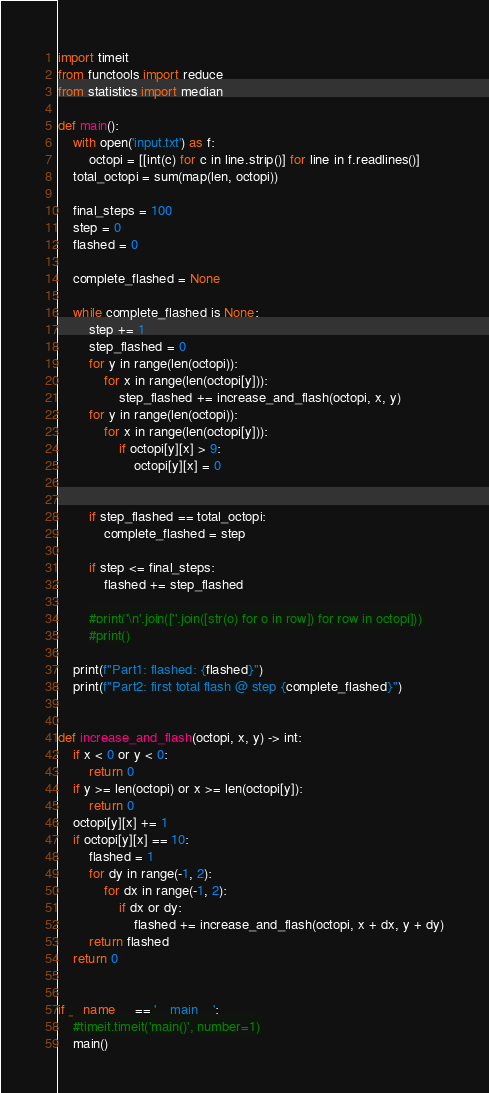Convert code to text. <code><loc_0><loc_0><loc_500><loc_500><_Python_>import timeit
from functools import reduce
from statistics import median

def main():
    with open('input.txt') as f:
        octopi = [[int(c) for c in line.strip()] for line in f.readlines()]
    total_octopi = sum(map(len, octopi))
    
    final_steps = 100
    step = 0
    flashed = 0

    complete_flashed = None

    while complete_flashed is None:
        step += 1
        step_flashed = 0
        for y in range(len(octopi)):
            for x in range(len(octopi[y])):
                step_flashed += increase_and_flash(octopi, x, y)
        for y in range(len(octopi)):
            for x in range(len(octopi[y])):
                if octopi[y][x] > 9:
                    octopi[y][x] = 0
        
        
        if step_flashed == total_octopi:
            complete_flashed = step

        if step <= final_steps:
            flashed += step_flashed
    
        #print('\n'.join([''.join([str(o) for o in row]) for row in octopi]))
        #print()

    print(f"Part1: flashed: {flashed}")
    print(f"Part2: first total flash @ step {complete_flashed}")
    

def increase_and_flash(octopi, x, y) -> int:
    if x < 0 or y < 0:
        return 0
    if y >= len(octopi) or x >= len(octopi[y]):
        return 0
    octopi[y][x] += 1
    if octopi[y][x] == 10:
        flashed = 1
        for dy in range(-1, 2):
            for dx in range(-1, 2):
                if dx or dy:
                    flashed += increase_and_flash(octopi, x + dx, y + dy)
        return flashed
    return 0
    

if __name__ == '__main__':
    #timeit.timeit('main()', number=1)
    main()
</code> 